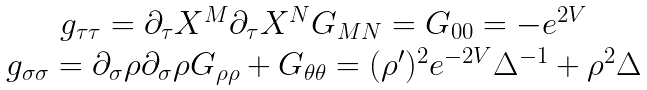Convert formula to latex. <formula><loc_0><loc_0><loc_500><loc_500>\begin{array} { c } g _ { \tau \tau } = \partial _ { \tau } X ^ { M } \partial _ { \tau } X ^ { N } G _ { M N } = G _ { 0 0 } = - e ^ { 2 V } \\ g _ { \sigma \sigma } = \partial _ { \sigma } \rho \partial _ { \sigma } \rho G _ { \rho \rho } + G _ { \theta \theta } = ( \rho ^ { \prime } ) ^ { 2 } e ^ { - 2 V } \Delta ^ { - 1 } + \rho ^ { 2 } \Delta \end{array}</formula> 